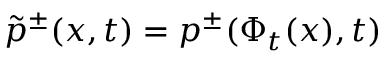<formula> <loc_0><loc_0><loc_500><loc_500>\tilde { p } ^ { \pm } ( x , t ) = p ^ { \pm } ( \Phi _ { t } ( x ) , t )</formula> 